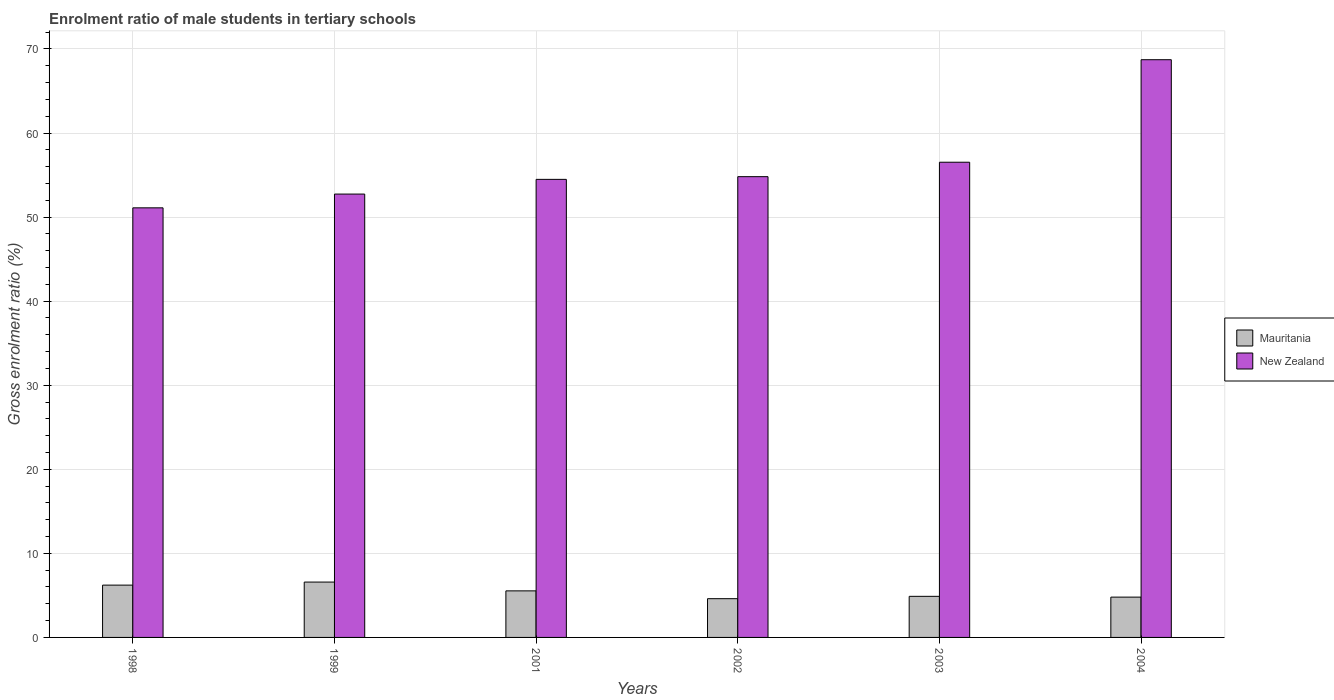How many different coloured bars are there?
Provide a short and direct response. 2. How many bars are there on the 3rd tick from the left?
Offer a very short reply. 2. What is the label of the 5th group of bars from the left?
Make the answer very short. 2003. In how many cases, is the number of bars for a given year not equal to the number of legend labels?
Your response must be concise. 0. What is the enrolment ratio of male students in tertiary schools in New Zealand in 2001?
Your answer should be very brief. 54.49. Across all years, what is the maximum enrolment ratio of male students in tertiary schools in Mauritania?
Ensure brevity in your answer.  6.58. Across all years, what is the minimum enrolment ratio of male students in tertiary schools in Mauritania?
Give a very brief answer. 4.61. In which year was the enrolment ratio of male students in tertiary schools in New Zealand minimum?
Your response must be concise. 1998. What is the total enrolment ratio of male students in tertiary schools in New Zealand in the graph?
Keep it short and to the point. 338.37. What is the difference between the enrolment ratio of male students in tertiary schools in Mauritania in 2001 and that in 2002?
Keep it short and to the point. 0.93. What is the difference between the enrolment ratio of male students in tertiary schools in New Zealand in 2003 and the enrolment ratio of male students in tertiary schools in Mauritania in 2004?
Offer a terse response. 51.73. What is the average enrolment ratio of male students in tertiary schools in New Zealand per year?
Your answer should be very brief. 56.4. In the year 1999, what is the difference between the enrolment ratio of male students in tertiary schools in Mauritania and enrolment ratio of male students in tertiary schools in New Zealand?
Offer a terse response. -46.15. In how many years, is the enrolment ratio of male students in tertiary schools in Mauritania greater than 70 %?
Offer a terse response. 0. What is the ratio of the enrolment ratio of male students in tertiary schools in Mauritania in 2002 to that in 2003?
Provide a succinct answer. 0.94. Is the difference between the enrolment ratio of male students in tertiary schools in Mauritania in 1999 and 2003 greater than the difference between the enrolment ratio of male students in tertiary schools in New Zealand in 1999 and 2003?
Ensure brevity in your answer.  Yes. What is the difference between the highest and the second highest enrolment ratio of male students in tertiary schools in Mauritania?
Your answer should be compact. 0.36. What is the difference between the highest and the lowest enrolment ratio of male students in tertiary schools in New Zealand?
Offer a very short reply. 17.62. In how many years, is the enrolment ratio of male students in tertiary schools in Mauritania greater than the average enrolment ratio of male students in tertiary schools in Mauritania taken over all years?
Give a very brief answer. 3. Is the sum of the enrolment ratio of male students in tertiary schools in Mauritania in 2003 and 2004 greater than the maximum enrolment ratio of male students in tertiary schools in New Zealand across all years?
Make the answer very short. No. What does the 1st bar from the left in 2001 represents?
Ensure brevity in your answer.  Mauritania. What does the 2nd bar from the right in 2003 represents?
Your response must be concise. Mauritania. How many bars are there?
Ensure brevity in your answer.  12. Where does the legend appear in the graph?
Offer a terse response. Center right. How are the legend labels stacked?
Ensure brevity in your answer.  Vertical. What is the title of the graph?
Give a very brief answer. Enrolment ratio of male students in tertiary schools. Does "Mongolia" appear as one of the legend labels in the graph?
Provide a short and direct response. No. What is the label or title of the X-axis?
Make the answer very short. Years. What is the label or title of the Y-axis?
Your response must be concise. Gross enrolment ratio (%). What is the Gross enrolment ratio (%) of Mauritania in 1998?
Provide a succinct answer. 6.22. What is the Gross enrolment ratio (%) in New Zealand in 1998?
Your response must be concise. 51.1. What is the Gross enrolment ratio (%) in Mauritania in 1999?
Provide a short and direct response. 6.58. What is the Gross enrolment ratio (%) in New Zealand in 1999?
Keep it short and to the point. 52.74. What is the Gross enrolment ratio (%) of Mauritania in 2001?
Your answer should be compact. 5.54. What is the Gross enrolment ratio (%) in New Zealand in 2001?
Offer a terse response. 54.49. What is the Gross enrolment ratio (%) of Mauritania in 2002?
Offer a very short reply. 4.61. What is the Gross enrolment ratio (%) of New Zealand in 2002?
Ensure brevity in your answer.  54.81. What is the Gross enrolment ratio (%) in Mauritania in 2003?
Provide a succinct answer. 4.89. What is the Gross enrolment ratio (%) of New Zealand in 2003?
Offer a terse response. 56.52. What is the Gross enrolment ratio (%) in Mauritania in 2004?
Keep it short and to the point. 4.8. What is the Gross enrolment ratio (%) in New Zealand in 2004?
Offer a very short reply. 68.72. Across all years, what is the maximum Gross enrolment ratio (%) in Mauritania?
Your answer should be very brief. 6.58. Across all years, what is the maximum Gross enrolment ratio (%) of New Zealand?
Your response must be concise. 68.72. Across all years, what is the minimum Gross enrolment ratio (%) of Mauritania?
Your response must be concise. 4.61. Across all years, what is the minimum Gross enrolment ratio (%) of New Zealand?
Offer a very short reply. 51.1. What is the total Gross enrolment ratio (%) of Mauritania in the graph?
Offer a very short reply. 32.64. What is the total Gross enrolment ratio (%) in New Zealand in the graph?
Your answer should be compact. 338.37. What is the difference between the Gross enrolment ratio (%) in Mauritania in 1998 and that in 1999?
Keep it short and to the point. -0.36. What is the difference between the Gross enrolment ratio (%) of New Zealand in 1998 and that in 1999?
Offer a very short reply. -1.64. What is the difference between the Gross enrolment ratio (%) in Mauritania in 1998 and that in 2001?
Make the answer very short. 0.68. What is the difference between the Gross enrolment ratio (%) of New Zealand in 1998 and that in 2001?
Keep it short and to the point. -3.39. What is the difference between the Gross enrolment ratio (%) in Mauritania in 1998 and that in 2002?
Keep it short and to the point. 1.61. What is the difference between the Gross enrolment ratio (%) of New Zealand in 1998 and that in 2002?
Your response must be concise. -3.71. What is the difference between the Gross enrolment ratio (%) in Mauritania in 1998 and that in 2003?
Provide a succinct answer. 1.33. What is the difference between the Gross enrolment ratio (%) of New Zealand in 1998 and that in 2003?
Offer a terse response. -5.42. What is the difference between the Gross enrolment ratio (%) of Mauritania in 1998 and that in 2004?
Ensure brevity in your answer.  1.43. What is the difference between the Gross enrolment ratio (%) in New Zealand in 1998 and that in 2004?
Offer a very short reply. -17.62. What is the difference between the Gross enrolment ratio (%) in Mauritania in 1999 and that in 2001?
Ensure brevity in your answer.  1.05. What is the difference between the Gross enrolment ratio (%) in New Zealand in 1999 and that in 2001?
Your response must be concise. -1.75. What is the difference between the Gross enrolment ratio (%) in Mauritania in 1999 and that in 2002?
Offer a very short reply. 1.98. What is the difference between the Gross enrolment ratio (%) of New Zealand in 1999 and that in 2002?
Make the answer very short. -2.07. What is the difference between the Gross enrolment ratio (%) in Mauritania in 1999 and that in 2003?
Offer a very short reply. 1.7. What is the difference between the Gross enrolment ratio (%) in New Zealand in 1999 and that in 2003?
Give a very brief answer. -3.79. What is the difference between the Gross enrolment ratio (%) in Mauritania in 1999 and that in 2004?
Your answer should be compact. 1.79. What is the difference between the Gross enrolment ratio (%) in New Zealand in 1999 and that in 2004?
Offer a terse response. -15.98. What is the difference between the Gross enrolment ratio (%) of Mauritania in 2001 and that in 2002?
Make the answer very short. 0.93. What is the difference between the Gross enrolment ratio (%) of New Zealand in 2001 and that in 2002?
Your response must be concise. -0.32. What is the difference between the Gross enrolment ratio (%) in Mauritania in 2001 and that in 2003?
Your answer should be compact. 0.65. What is the difference between the Gross enrolment ratio (%) in New Zealand in 2001 and that in 2003?
Keep it short and to the point. -2.04. What is the difference between the Gross enrolment ratio (%) in Mauritania in 2001 and that in 2004?
Provide a succinct answer. 0.74. What is the difference between the Gross enrolment ratio (%) of New Zealand in 2001 and that in 2004?
Keep it short and to the point. -14.23. What is the difference between the Gross enrolment ratio (%) of Mauritania in 2002 and that in 2003?
Provide a succinct answer. -0.28. What is the difference between the Gross enrolment ratio (%) in New Zealand in 2002 and that in 2003?
Your answer should be compact. -1.72. What is the difference between the Gross enrolment ratio (%) of Mauritania in 2002 and that in 2004?
Provide a succinct answer. -0.19. What is the difference between the Gross enrolment ratio (%) of New Zealand in 2002 and that in 2004?
Give a very brief answer. -13.91. What is the difference between the Gross enrolment ratio (%) of Mauritania in 2003 and that in 2004?
Make the answer very short. 0.09. What is the difference between the Gross enrolment ratio (%) of New Zealand in 2003 and that in 2004?
Offer a terse response. -12.19. What is the difference between the Gross enrolment ratio (%) of Mauritania in 1998 and the Gross enrolment ratio (%) of New Zealand in 1999?
Provide a succinct answer. -46.51. What is the difference between the Gross enrolment ratio (%) in Mauritania in 1998 and the Gross enrolment ratio (%) in New Zealand in 2001?
Provide a short and direct response. -48.26. What is the difference between the Gross enrolment ratio (%) of Mauritania in 1998 and the Gross enrolment ratio (%) of New Zealand in 2002?
Your response must be concise. -48.59. What is the difference between the Gross enrolment ratio (%) in Mauritania in 1998 and the Gross enrolment ratio (%) in New Zealand in 2003?
Your response must be concise. -50.3. What is the difference between the Gross enrolment ratio (%) in Mauritania in 1998 and the Gross enrolment ratio (%) in New Zealand in 2004?
Your answer should be very brief. -62.5. What is the difference between the Gross enrolment ratio (%) in Mauritania in 1999 and the Gross enrolment ratio (%) in New Zealand in 2001?
Provide a short and direct response. -47.9. What is the difference between the Gross enrolment ratio (%) of Mauritania in 1999 and the Gross enrolment ratio (%) of New Zealand in 2002?
Provide a short and direct response. -48.22. What is the difference between the Gross enrolment ratio (%) in Mauritania in 1999 and the Gross enrolment ratio (%) in New Zealand in 2003?
Provide a succinct answer. -49.94. What is the difference between the Gross enrolment ratio (%) in Mauritania in 1999 and the Gross enrolment ratio (%) in New Zealand in 2004?
Provide a succinct answer. -62.13. What is the difference between the Gross enrolment ratio (%) in Mauritania in 2001 and the Gross enrolment ratio (%) in New Zealand in 2002?
Give a very brief answer. -49.27. What is the difference between the Gross enrolment ratio (%) of Mauritania in 2001 and the Gross enrolment ratio (%) of New Zealand in 2003?
Keep it short and to the point. -50.99. What is the difference between the Gross enrolment ratio (%) of Mauritania in 2001 and the Gross enrolment ratio (%) of New Zealand in 2004?
Keep it short and to the point. -63.18. What is the difference between the Gross enrolment ratio (%) of Mauritania in 2002 and the Gross enrolment ratio (%) of New Zealand in 2003?
Your answer should be very brief. -51.92. What is the difference between the Gross enrolment ratio (%) of Mauritania in 2002 and the Gross enrolment ratio (%) of New Zealand in 2004?
Ensure brevity in your answer.  -64.11. What is the difference between the Gross enrolment ratio (%) in Mauritania in 2003 and the Gross enrolment ratio (%) in New Zealand in 2004?
Provide a short and direct response. -63.83. What is the average Gross enrolment ratio (%) of Mauritania per year?
Give a very brief answer. 5.44. What is the average Gross enrolment ratio (%) of New Zealand per year?
Your answer should be compact. 56.4. In the year 1998, what is the difference between the Gross enrolment ratio (%) of Mauritania and Gross enrolment ratio (%) of New Zealand?
Make the answer very short. -44.88. In the year 1999, what is the difference between the Gross enrolment ratio (%) in Mauritania and Gross enrolment ratio (%) in New Zealand?
Provide a short and direct response. -46.15. In the year 2001, what is the difference between the Gross enrolment ratio (%) in Mauritania and Gross enrolment ratio (%) in New Zealand?
Ensure brevity in your answer.  -48.95. In the year 2002, what is the difference between the Gross enrolment ratio (%) in Mauritania and Gross enrolment ratio (%) in New Zealand?
Your answer should be very brief. -50.2. In the year 2003, what is the difference between the Gross enrolment ratio (%) of Mauritania and Gross enrolment ratio (%) of New Zealand?
Provide a succinct answer. -51.64. In the year 2004, what is the difference between the Gross enrolment ratio (%) of Mauritania and Gross enrolment ratio (%) of New Zealand?
Your response must be concise. -63.92. What is the ratio of the Gross enrolment ratio (%) of Mauritania in 1998 to that in 1999?
Ensure brevity in your answer.  0.94. What is the ratio of the Gross enrolment ratio (%) in Mauritania in 1998 to that in 2001?
Keep it short and to the point. 1.12. What is the ratio of the Gross enrolment ratio (%) of New Zealand in 1998 to that in 2001?
Provide a succinct answer. 0.94. What is the ratio of the Gross enrolment ratio (%) of Mauritania in 1998 to that in 2002?
Your answer should be compact. 1.35. What is the ratio of the Gross enrolment ratio (%) in New Zealand in 1998 to that in 2002?
Keep it short and to the point. 0.93. What is the ratio of the Gross enrolment ratio (%) in Mauritania in 1998 to that in 2003?
Offer a terse response. 1.27. What is the ratio of the Gross enrolment ratio (%) of New Zealand in 1998 to that in 2003?
Give a very brief answer. 0.9. What is the ratio of the Gross enrolment ratio (%) of Mauritania in 1998 to that in 2004?
Provide a succinct answer. 1.3. What is the ratio of the Gross enrolment ratio (%) of New Zealand in 1998 to that in 2004?
Offer a terse response. 0.74. What is the ratio of the Gross enrolment ratio (%) in Mauritania in 1999 to that in 2001?
Your answer should be very brief. 1.19. What is the ratio of the Gross enrolment ratio (%) of New Zealand in 1999 to that in 2001?
Provide a succinct answer. 0.97. What is the ratio of the Gross enrolment ratio (%) of Mauritania in 1999 to that in 2002?
Make the answer very short. 1.43. What is the ratio of the Gross enrolment ratio (%) in New Zealand in 1999 to that in 2002?
Keep it short and to the point. 0.96. What is the ratio of the Gross enrolment ratio (%) of Mauritania in 1999 to that in 2003?
Your response must be concise. 1.35. What is the ratio of the Gross enrolment ratio (%) in New Zealand in 1999 to that in 2003?
Provide a short and direct response. 0.93. What is the ratio of the Gross enrolment ratio (%) in Mauritania in 1999 to that in 2004?
Your response must be concise. 1.37. What is the ratio of the Gross enrolment ratio (%) in New Zealand in 1999 to that in 2004?
Provide a short and direct response. 0.77. What is the ratio of the Gross enrolment ratio (%) of Mauritania in 2001 to that in 2002?
Give a very brief answer. 1.2. What is the ratio of the Gross enrolment ratio (%) of New Zealand in 2001 to that in 2002?
Ensure brevity in your answer.  0.99. What is the ratio of the Gross enrolment ratio (%) in Mauritania in 2001 to that in 2003?
Keep it short and to the point. 1.13. What is the ratio of the Gross enrolment ratio (%) in New Zealand in 2001 to that in 2003?
Provide a succinct answer. 0.96. What is the ratio of the Gross enrolment ratio (%) in Mauritania in 2001 to that in 2004?
Give a very brief answer. 1.16. What is the ratio of the Gross enrolment ratio (%) in New Zealand in 2001 to that in 2004?
Give a very brief answer. 0.79. What is the ratio of the Gross enrolment ratio (%) of Mauritania in 2002 to that in 2003?
Offer a very short reply. 0.94. What is the ratio of the Gross enrolment ratio (%) of New Zealand in 2002 to that in 2003?
Keep it short and to the point. 0.97. What is the ratio of the Gross enrolment ratio (%) in Mauritania in 2002 to that in 2004?
Your answer should be compact. 0.96. What is the ratio of the Gross enrolment ratio (%) of New Zealand in 2002 to that in 2004?
Offer a terse response. 0.8. What is the ratio of the Gross enrolment ratio (%) in Mauritania in 2003 to that in 2004?
Ensure brevity in your answer.  1.02. What is the ratio of the Gross enrolment ratio (%) of New Zealand in 2003 to that in 2004?
Your answer should be very brief. 0.82. What is the difference between the highest and the second highest Gross enrolment ratio (%) in Mauritania?
Give a very brief answer. 0.36. What is the difference between the highest and the second highest Gross enrolment ratio (%) of New Zealand?
Make the answer very short. 12.19. What is the difference between the highest and the lowest Gross enrolment ratio (%) in Mauritania?
Your response must be concise. 1.98. What is the difference between the highest and the lowest Gross enrolment ratio (%) in New Zealand?
Keep it short and to the point. 17.62. 